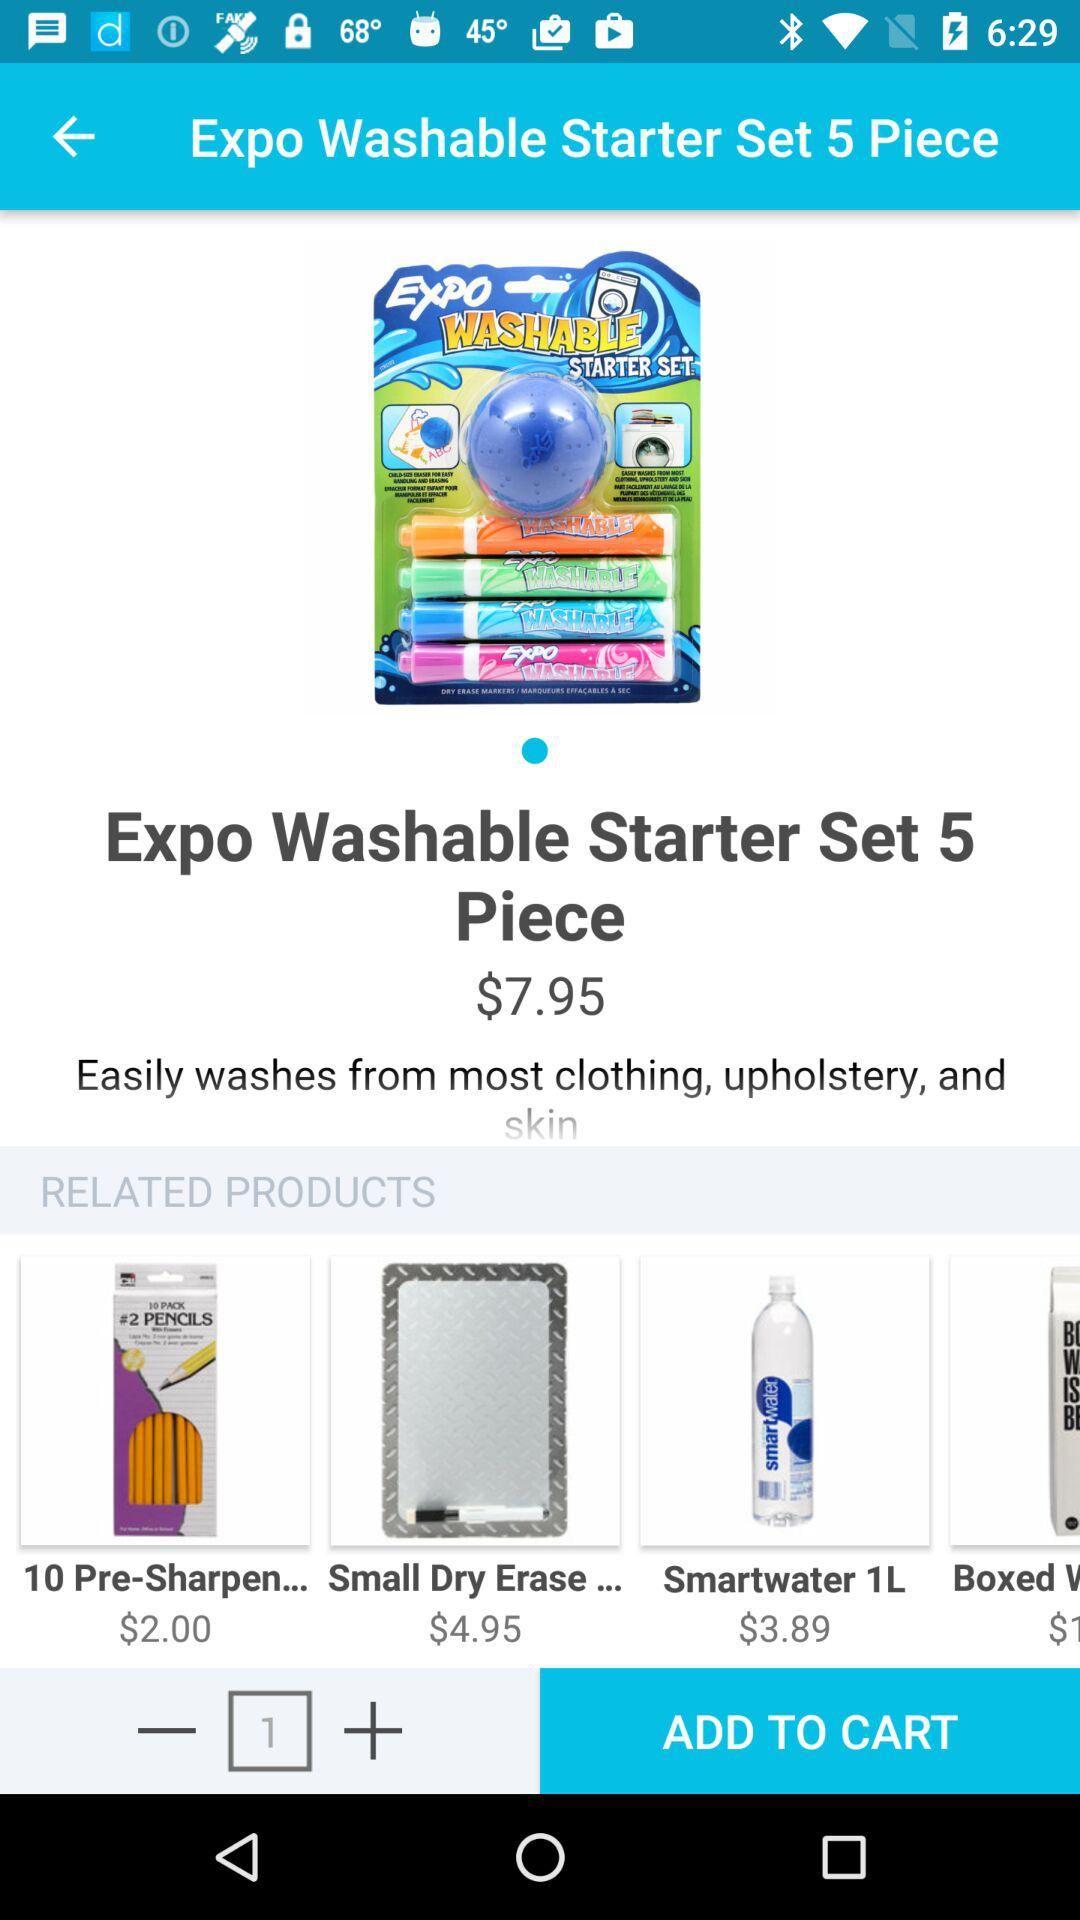What is the price of the "Expo Washable Starter Set"? The price of the "Expo Washable Starter Set" is $7.95. 